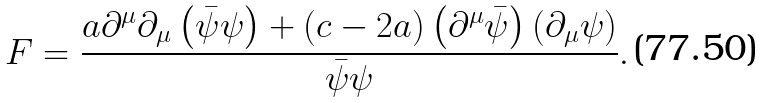<formula> <loc_0><loc_0><loc_500><loc_500>F = \frac { a \partial ^ { \mu } \partial _ { \mu } \left ( \bar { \psi } \psi \right ) + \left ( c - 2 a \right ) \left ( \partial ^ { \mu } \bar { \psi } \right ) \left ( \partial _ { \mu } \psi \right ) } { \bar { \psi } \psi } .</formula> 